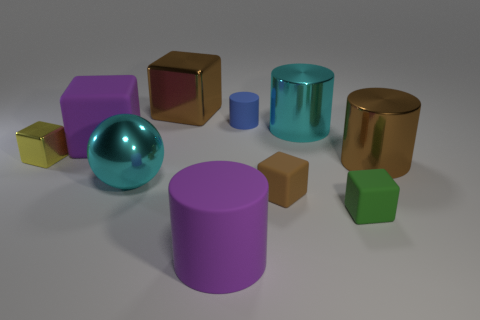Subtract all green cubes. How many cubes are left? 4 Subtract all yellow cubes. How many cubes are left? 4 Subtract 1 cylinders. How many cylinders are left? 3 Subtract all blue blocks. Subtract all red cylinders. How many blocks are left? 5 Subtract all cylinders. How many objects are left? 6 Subtract 0 yellow cylinders. How many objects are left? 10 Subtract all blue cylinders. Subtract all green rubber things. How many objects are left? 8 Add 4 purple matte objects. How many purple matte objects are left? 6 Add 6 large spheres. How many large spheres exist? 7 